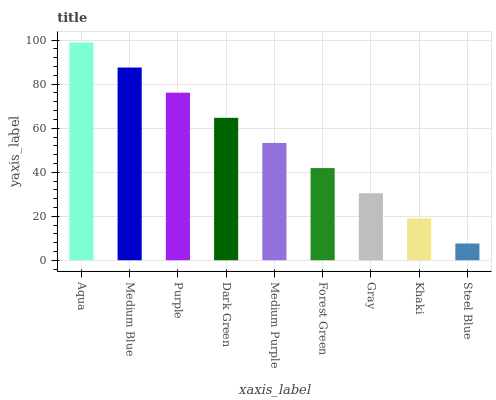Is Steel Blue the minimum?
Answer yes or no. Yes. Is Aqua the maximum?
Answer yes or no. Yes. Is Medium Blue the minimum?
Answer yes or no. No. Is Medium Blue the maximum?
Answer yes or no. No. Is Aqua greater than Medium Blue?
Answer yes or no. Yes. Is Medium Blue less than Aqua?
Answer yes or no. Yes. Is Medium Blue greater than Aqua?
Answer yes or no. No. Is Aqua less than Medium Blue?
Answer yes or no. No. Is Medium Purple the high median?
Answer yes or no. Yes. Is Medium Purple the low median?
Answer yes or no. Yes. Is Purple the high median?
Answer yes or no. No. Is Medium Blue the low median?
Answer yes or no. No. 